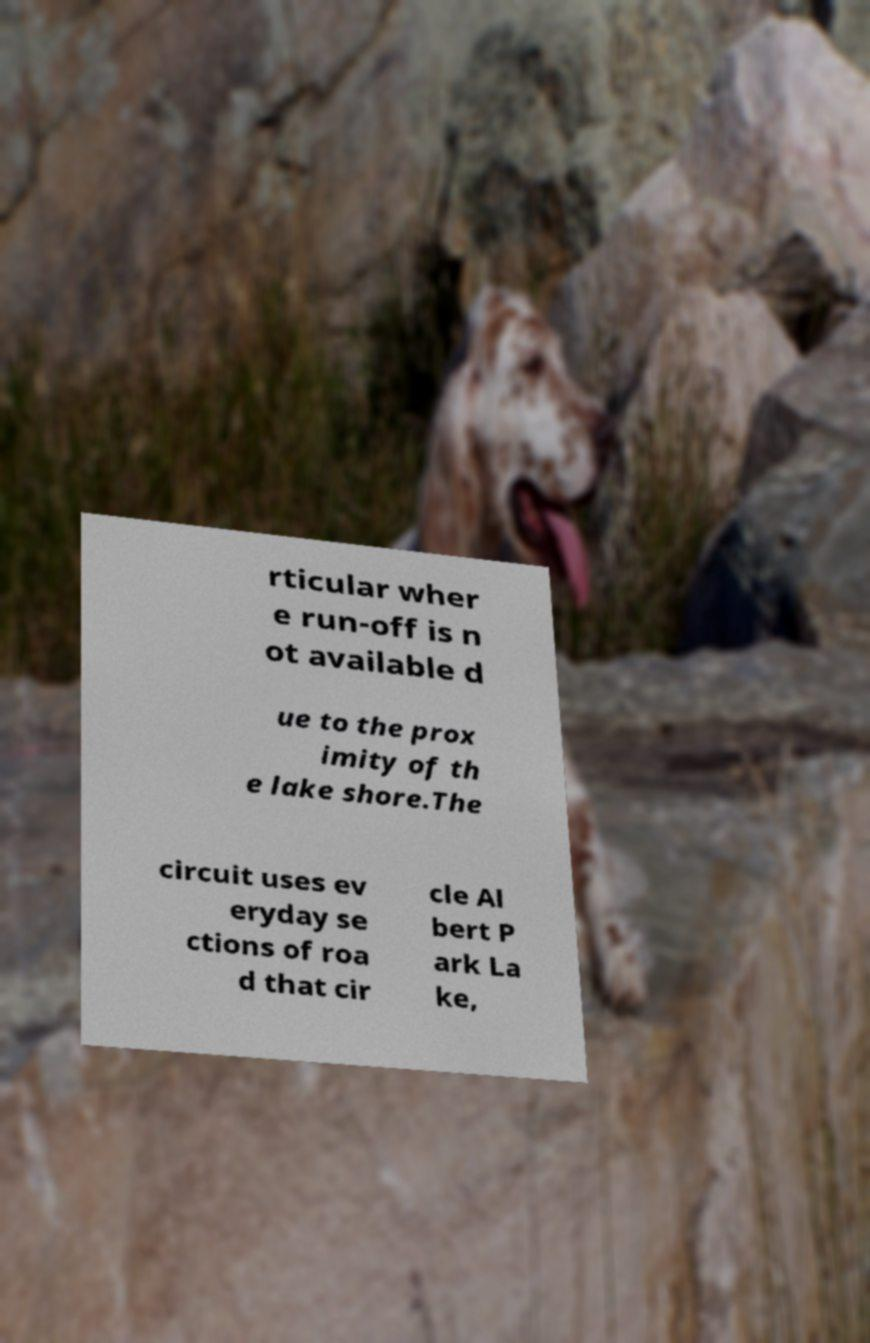Can you read and provide the text displayed in the image?This photo seems to have some interesting text. Can you extract and type it out for me? rticular wher e run-off is n ot available d ue to the prox imity of th e lake shore.The circuit uses ev eryday se ctions of roa d that cir cle Al bert P ark La ke, 